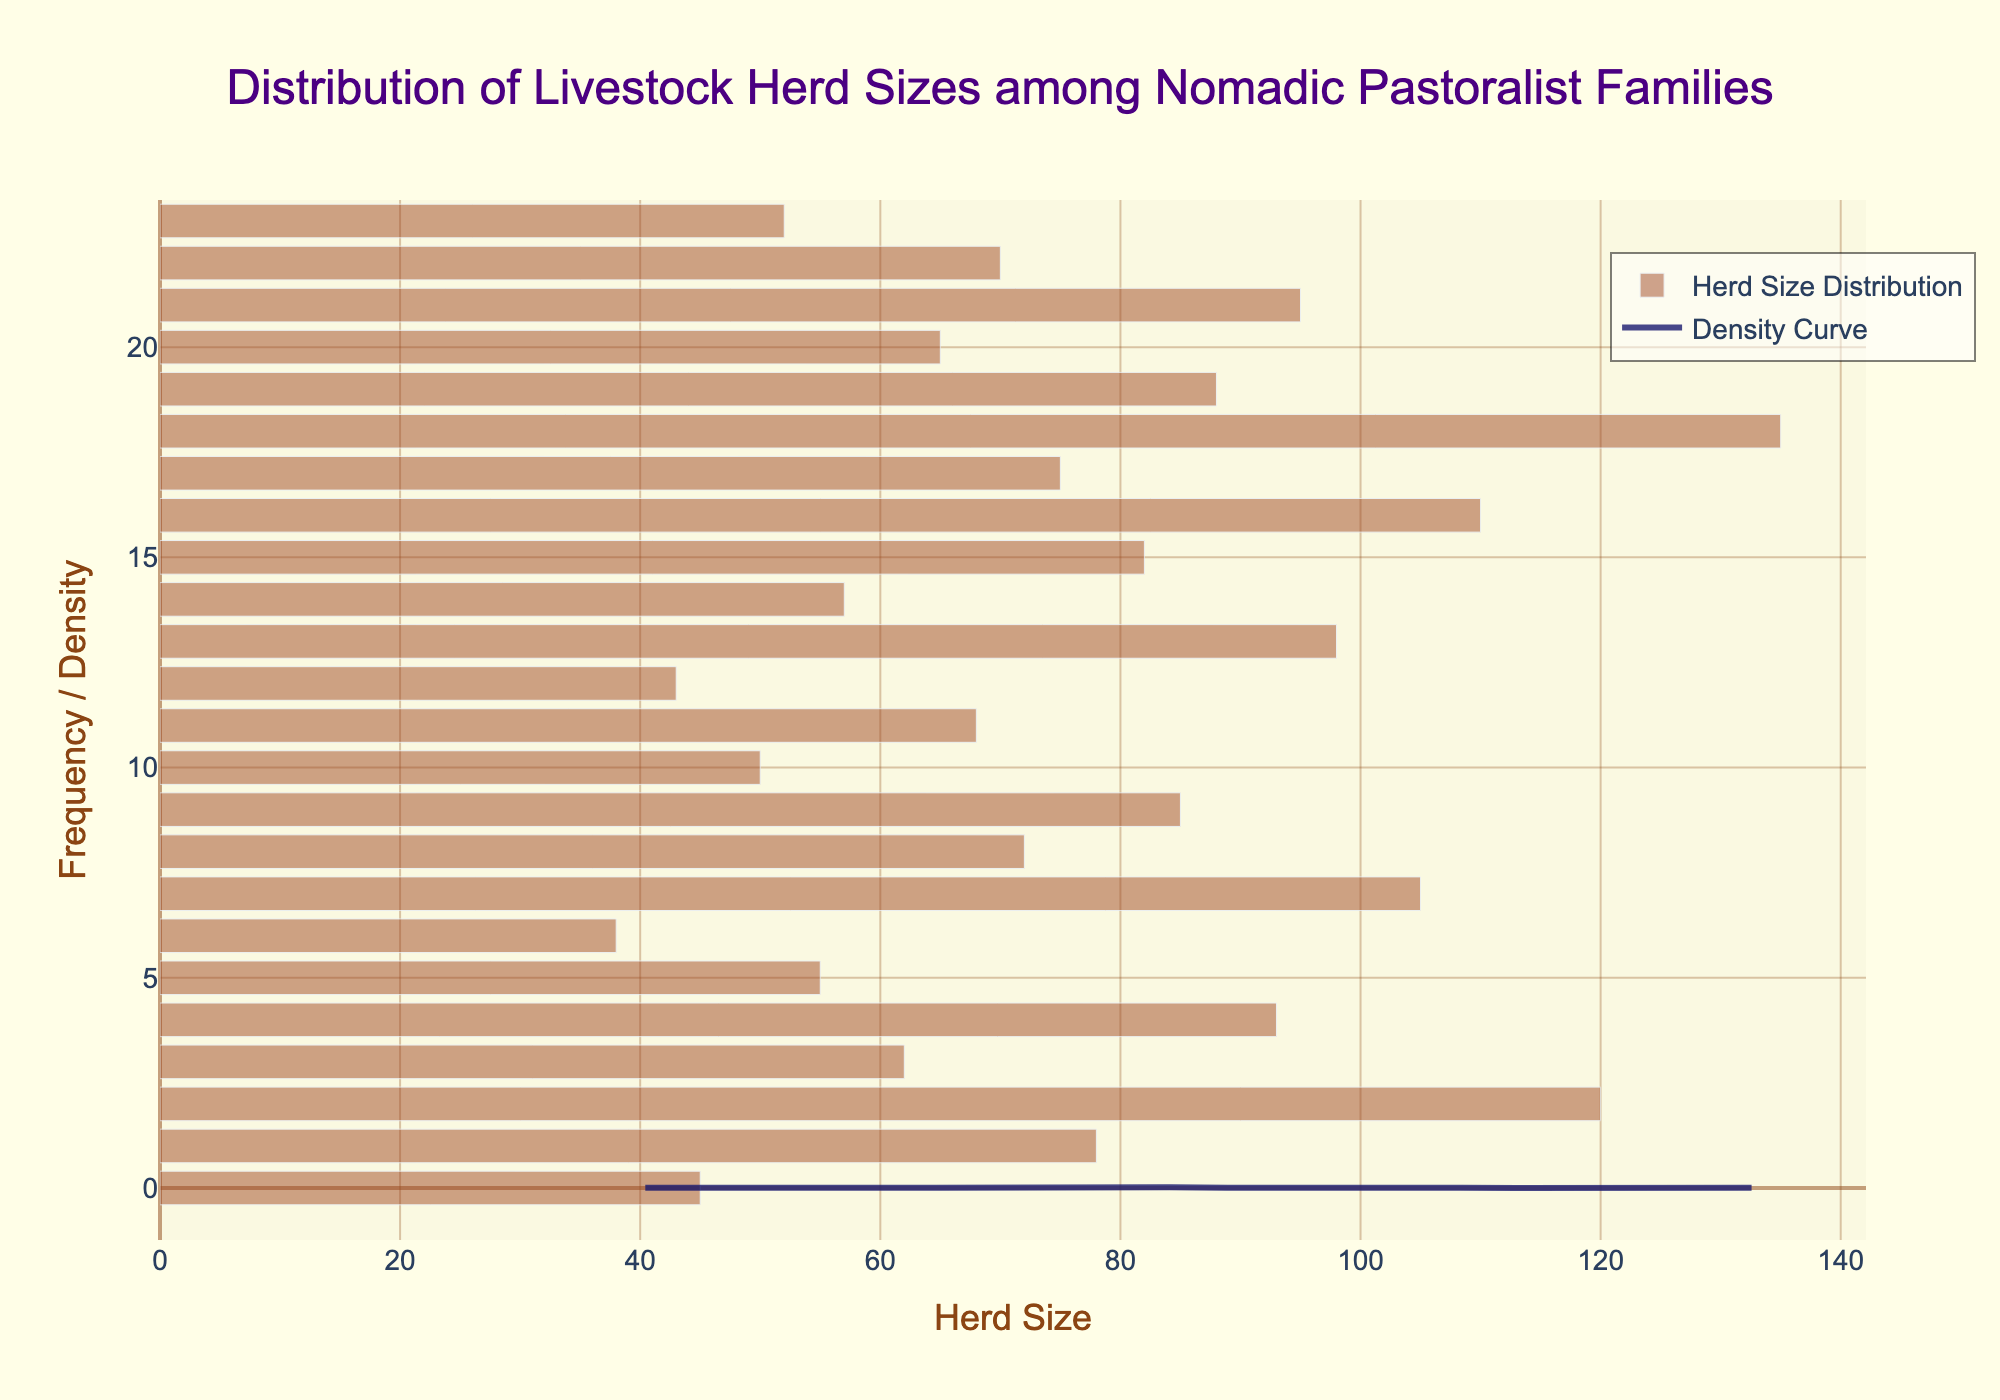What is the title of the figure? The title is usually located at the top of the figure. It summarizes what the figure is about. Here, the title is "Distribution of Livestock Herd Sizes among Nomadic Pastoralist Families."
Answer: Distribution of Livestock Herd Sizes among Nomadic Pastoralist Families What is the color of the bars in the histogram? The bars in the histogram are typically colored to make them visually distinct. The bars here are a shade of orange-brown.
Answer: Orange-brown What does the x-axis represent? The x-axis usually shows the variable being measured or categorized. In this case, it represents the livestock herd size.
Answer: Herd Size What is shown on the y-axis? The y-axis typically shows the frequency or density of the x-axis variable. Here, it shows the frequency or density of the herd sizes.
Answer: Frequency / Density Which family has the largest herd size, and what is that size? The largest herd size can be identified by locating the highest point on the histogram. The family with the largest herd size is Kel Ahaggar, with a herd size of 135.
Answer: Kel Ahaggar, 135 What is the range of herd sizes represented in the figure? The range is calculated by finding the difference between the smallest and largest herd sizes shown on the x-axis. The range here is from 38 to 135.
Answer: 38 to 135 How many families have a herd size above 100? By examining the x-axis and counting the bars that correspond to herd sizes above 100, we can determine the count. There are four families: Tuareg, Nafusa, Ait Atta, and Kel Ahaggar.
Answer: 4 What is the most common herd size range according to the histogram? The most common range can be identified by the tallest bar on the histogram. The most common herd size range is around 65-75.
Answer: 65-75 Compare the density curve with the histogram. How well do they align? The density curve (KDE) visually represents the smoothed distribution of the data and should follow the shape of the histogram closely. They align well if the peaks of the density curve match the heights of the histogram bars. The KDE and histogram align fairly well, indicating a good approximation of the data's distribution.
Answer: Fairly well What does the peak of the density curve suggest about the distribution of herd sizes? A peak in the density curve indicates the region where the data points are concentrated. The peak suggests that most families have herd sizes in the range of 65–75.
Answer: Most families have herd sizes in the range of 65-75 